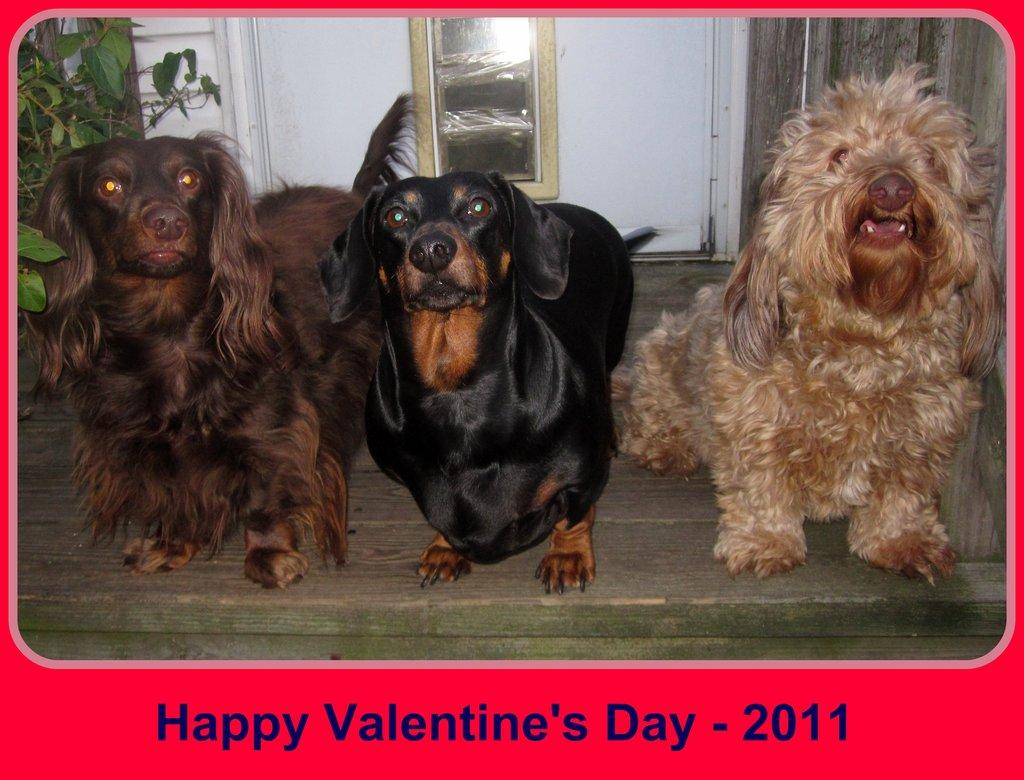What animals are present in the image? There are dogs in the image. What type of surface are the dogs on? The dogs are on a wooden surface. What can be observed around the edges of the image? The image has borders, and there is text on the borders. What type of operation is being performed on the dogs in the image? There is no operation being performed on the dogs in the image; they are simply sitting or standing on the wooden surface. 